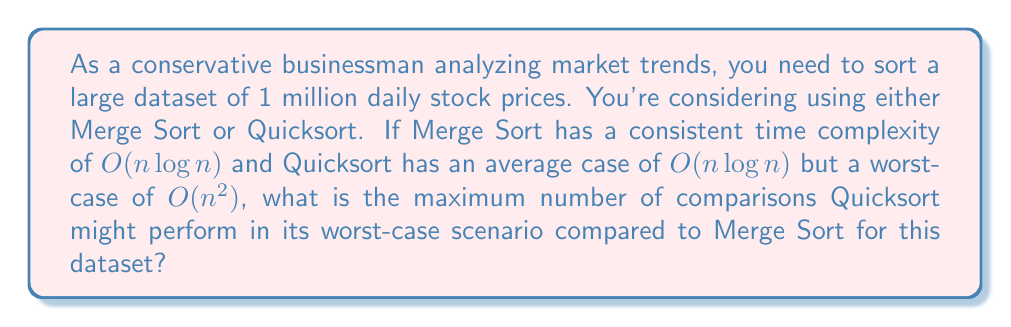Solve this math problem. Let's approach this step-by-step:

1) First, we need to understand the time complexities:
   - Merge Sort: $O(n \log n)$ consistently
   - Quicksort: $O(n^2)$ in worst case

2) For a dataset of 1 million items, $n = 10^6$

3) For Merge Sort:
   - Number of comparisons $\approx c_1 \cdot n \log n$
   - $\approx c_1 \cdot 10^6 \log 10^6$
   - $\approx c_1 \cdot 10^6 \cdot 6 \log 10$
   - $\approx 6c_1 \cdot 10^6 \log 10$

4) For Quicksort (worst case):
   - Number of comparisons $\approx c_2 \cdot n^2$
   - $\approx c_2 \cdot (10^6)^2$
   - $\approx c_2 \cdot 10^{12}$

5) The ratio of Quicksort (worst case) to Merge Sort:

   $$\frac{\text{Quicksort}}{\text{Merge Sort}} \approx \frac{c_2 \cdot 10^{12}}{6c_1 \cdot 10^6 \log 10} = \frac{c_2}{6c_1 \log 10} \cdot 10^6$$

6) Assuming $c_1$ and $c_2$ are similar (as they often are in practice), we can approximate them as equal. This gives us:

   $$\frac{\text{Quicksort}}{\text{Merge Sort}} \approx \frac{10^6}{6 \log 10} \approx 72,382$$

Therefore, in the worst-case scenario, Quicksort might perform approximately 72,382 times more comparisons than Merge Sort for this dataset.
Answer: Approximately 72,382 times more comparisons 